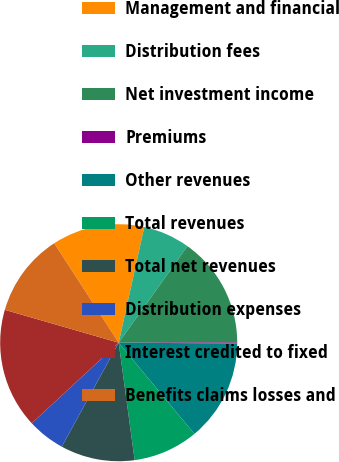Convert chart. <chart><loc_0><loc_0><loc_500><loc_500><pie_chart><fcel>Management and financial<fcel>Distribution fees<fcel>Net investment income<fcel>Premiums<fcel>Other revenues<fcel>Total revenues<fcel>Total net revenues<fcel>Distribution expenses<fcel>Interest credited to fixed<fcel>Benefits claims losses and<nl><fcel>12.62%<fcel>6.38%<fcel>15.12%<fcel>0.13%<fcel>13.87%<fcel>8.88%<fcel>10.12%<fcel>5.13%<fcel>16.37%<fcel>11.37%<nl></chart> 